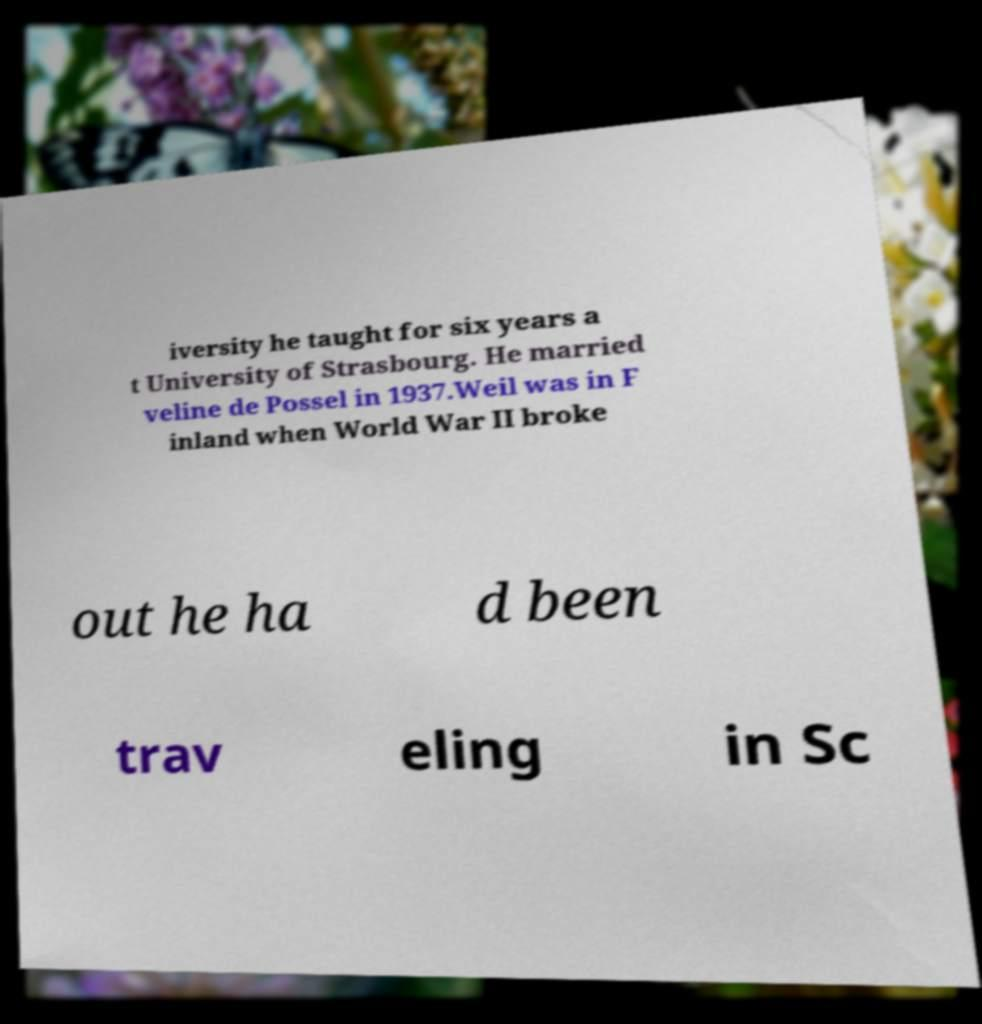What messages or text are displayed in this image? I need them in a readable, typed format. iversity he taught for six years a t University of Strasbourg. He married veline de Possel in 1937.Weil was in F inland when World War II broke out he ha d been trav eling in Sc 